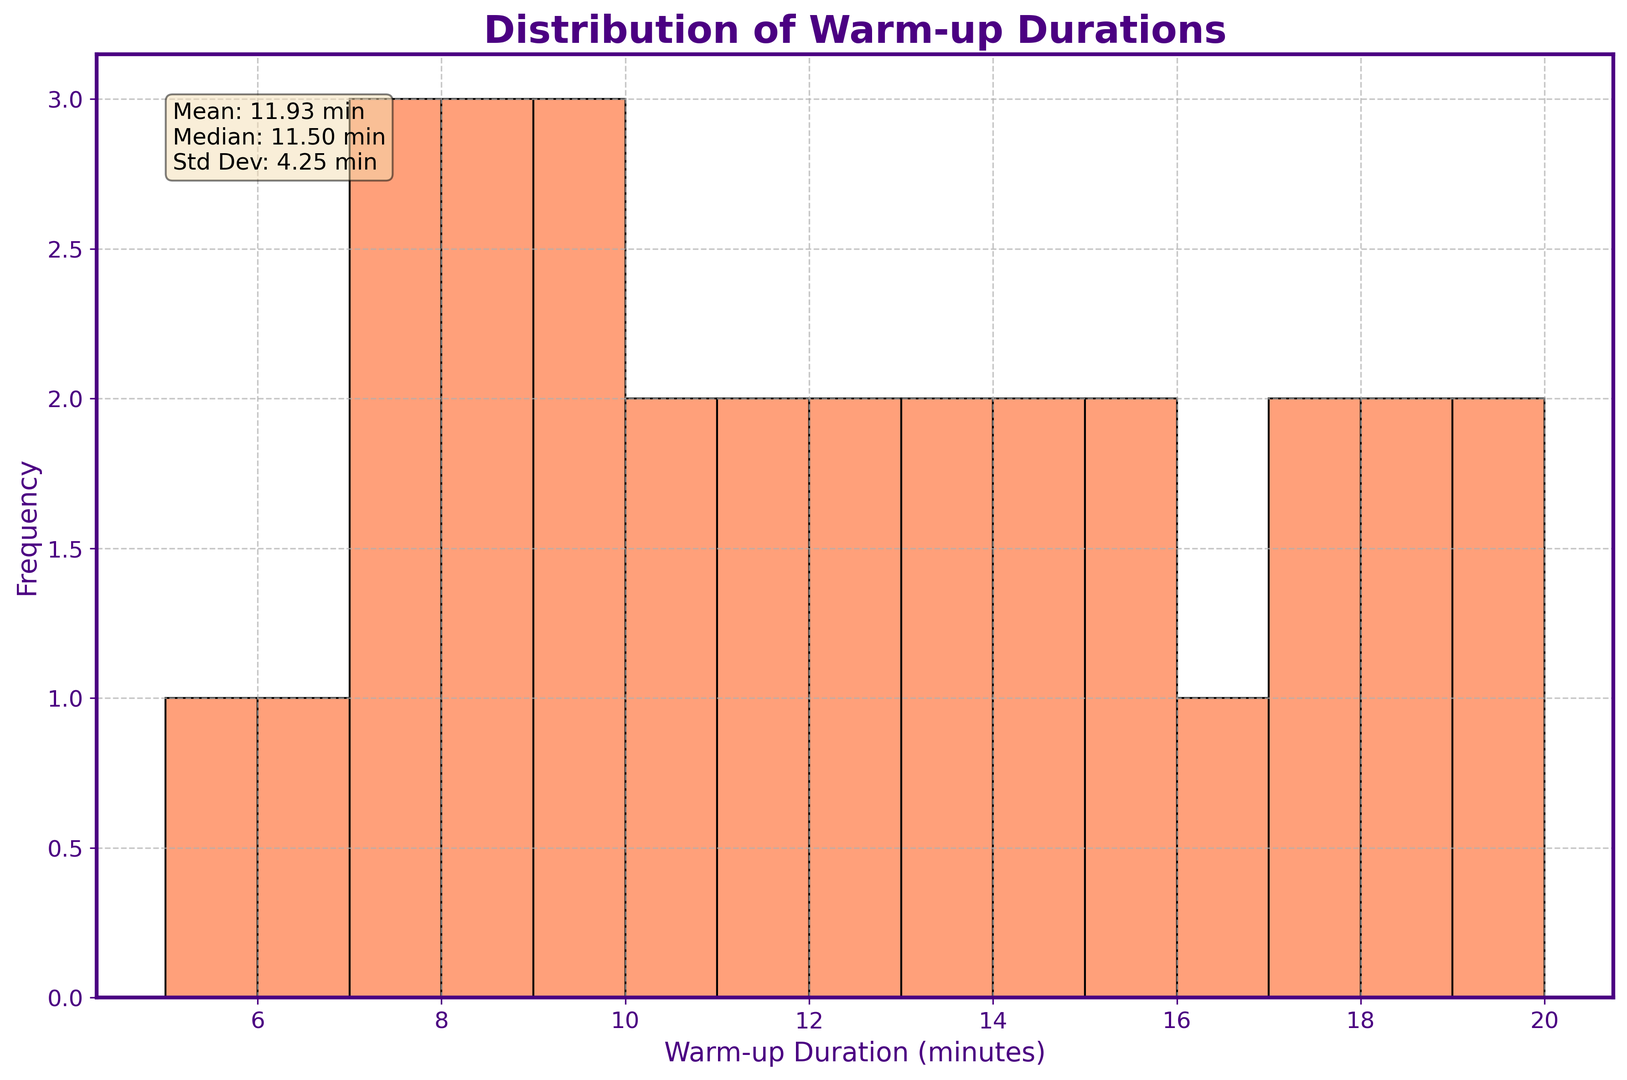What is the median warm-up duration? The median warm-up duration is noted in the text box within the figure under the "Mean, Median, Std Dev" section. The median value is directly provided.
Answer: 12 min How does the distribution of warm-up durations visually appear? By observing the histogram, one can see that the distribution of warm-up durations appears to be moderately spread out with a few peaks. The highest frequency lies in the range of about 5 to 10 minutes, and the distribution tails off towards longer durations.
Answer: Moderately spread with peaks in lower durations Which age group tends to have the longest warm-up durations? By analyzing the data points provided and the distribution, the 66+ age group consistently shows higher warm-up durations in the histogram, as indicated by the higher bars in the range of longer durations.
Answer: 66+ How does the mean warm-up duration compare to the median warm-up duration? The mean and median values are both given in the text box on the figure. The mean is 11.15 minutes and the median is 12 minutes, indicating that the mean is slightly lower than the median.
Answer: Mean < Median What is the standard deviation of warm-up durations? The standard deviation is explicitly mentioned in the text box in the figure as part of the descriptive statistics. It is listed as 3.92 minutes.
Answer: 3.92 min What can be inferred about participants aged 56-65 based on their warm-up durations? Participants aged 56-65 fall in the higher range of durations as indicated by the histogram. The bars corresponding to their durations (ranging from 14 to 17 minutes) show a consistent frequency, suggesting they spend more time warming up compared to younger groups.
Answer: They spend relatively more time warming up Which warm-up duration range has the highest frequency? Observing the highest bar in the histogram, the duration range with the highest frequency appears to be around 7 to 8 minutes.
Answer: 7-8 minutes Is there a wide variation in warm-up durations within the age group 36-45? By examining the histogram, it is noticeable that the duration values among participants aged 36-45 spread out mostly between 9 to 12 minutes. This shows a moderate range but not excessively wide.
Answer: Moderate variation 